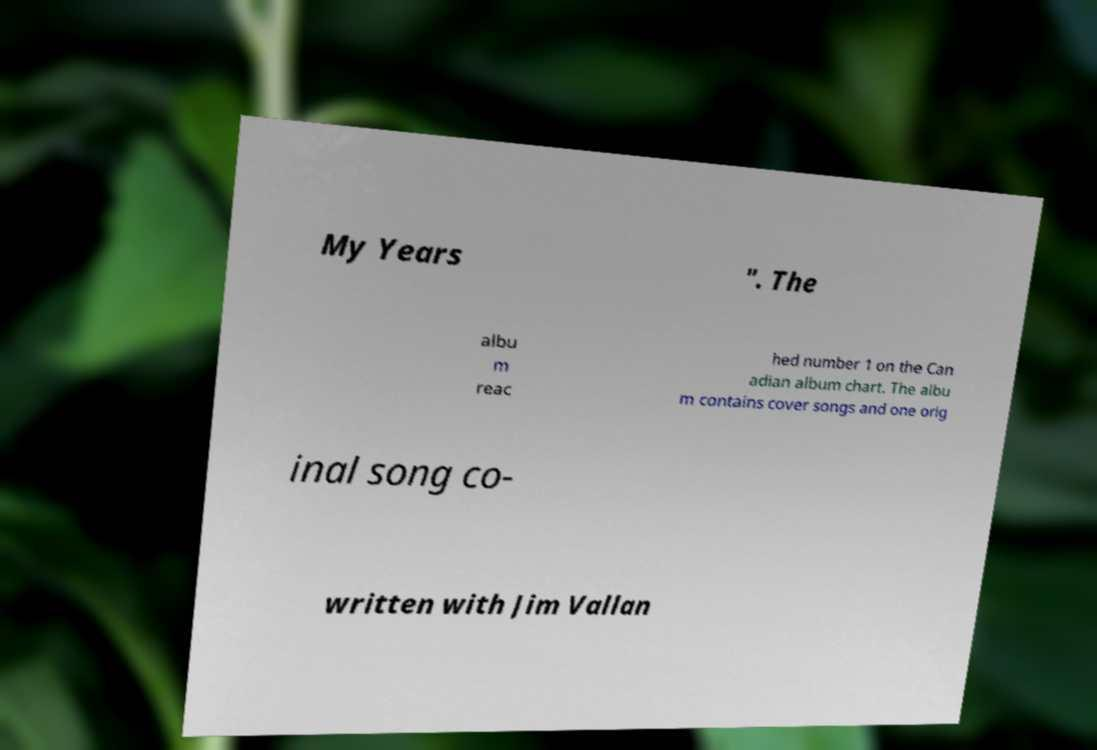There's text embedded in this image that I need extracted. Can you transcribe it verbatim? My Years ". The albu m reac hed number 1 on the Can adian album chart. The albu m contains cover songs and one orig inal song co- written with Jim Vallan 